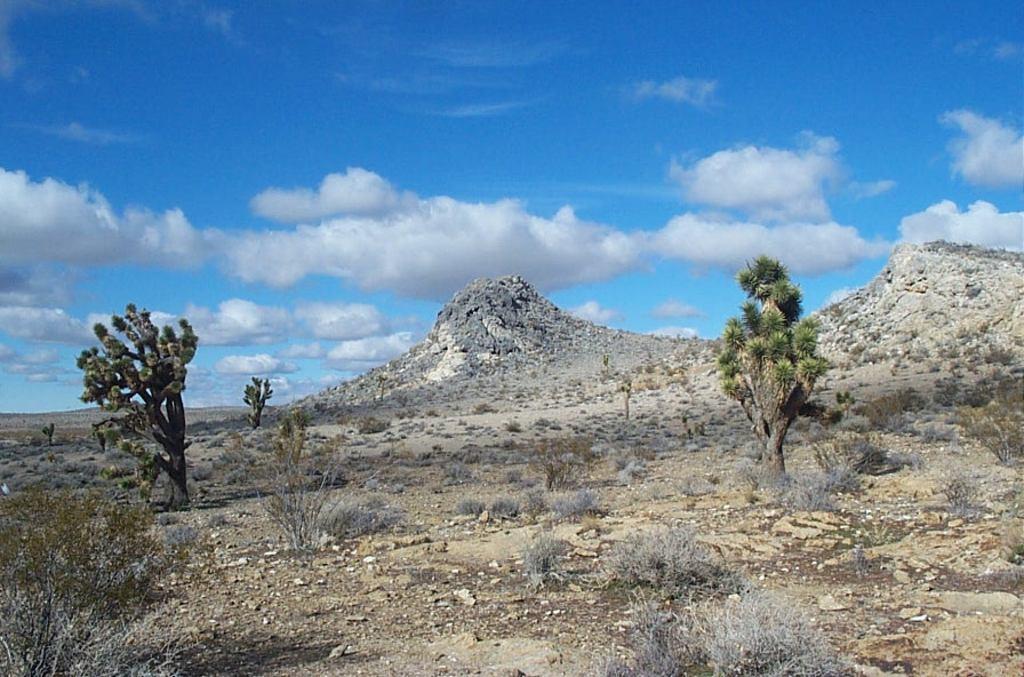Could you give a brief overview of what you see in this image? In this image we can see sky with clouds, hills, trees, plants, rocks and shrubs. 